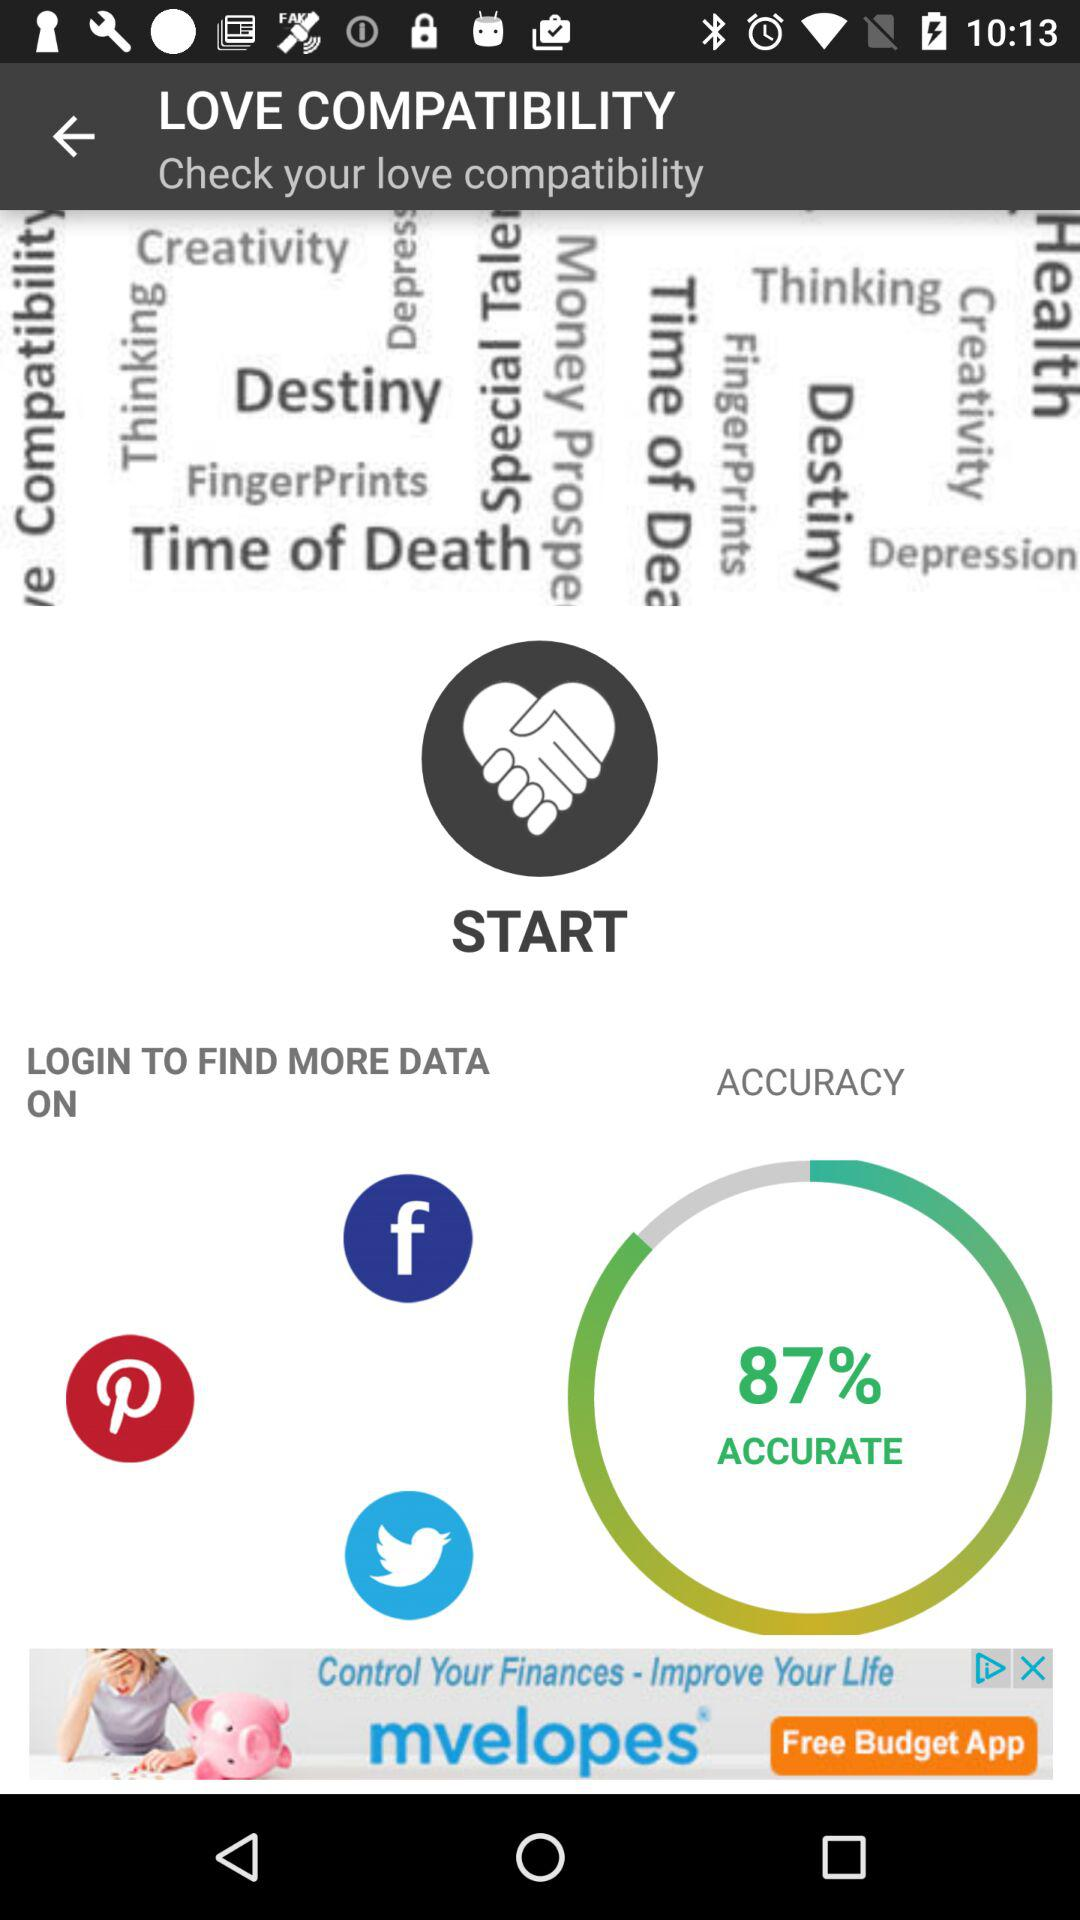What is the accuracy percentage? The accuracy percentage is 87. 